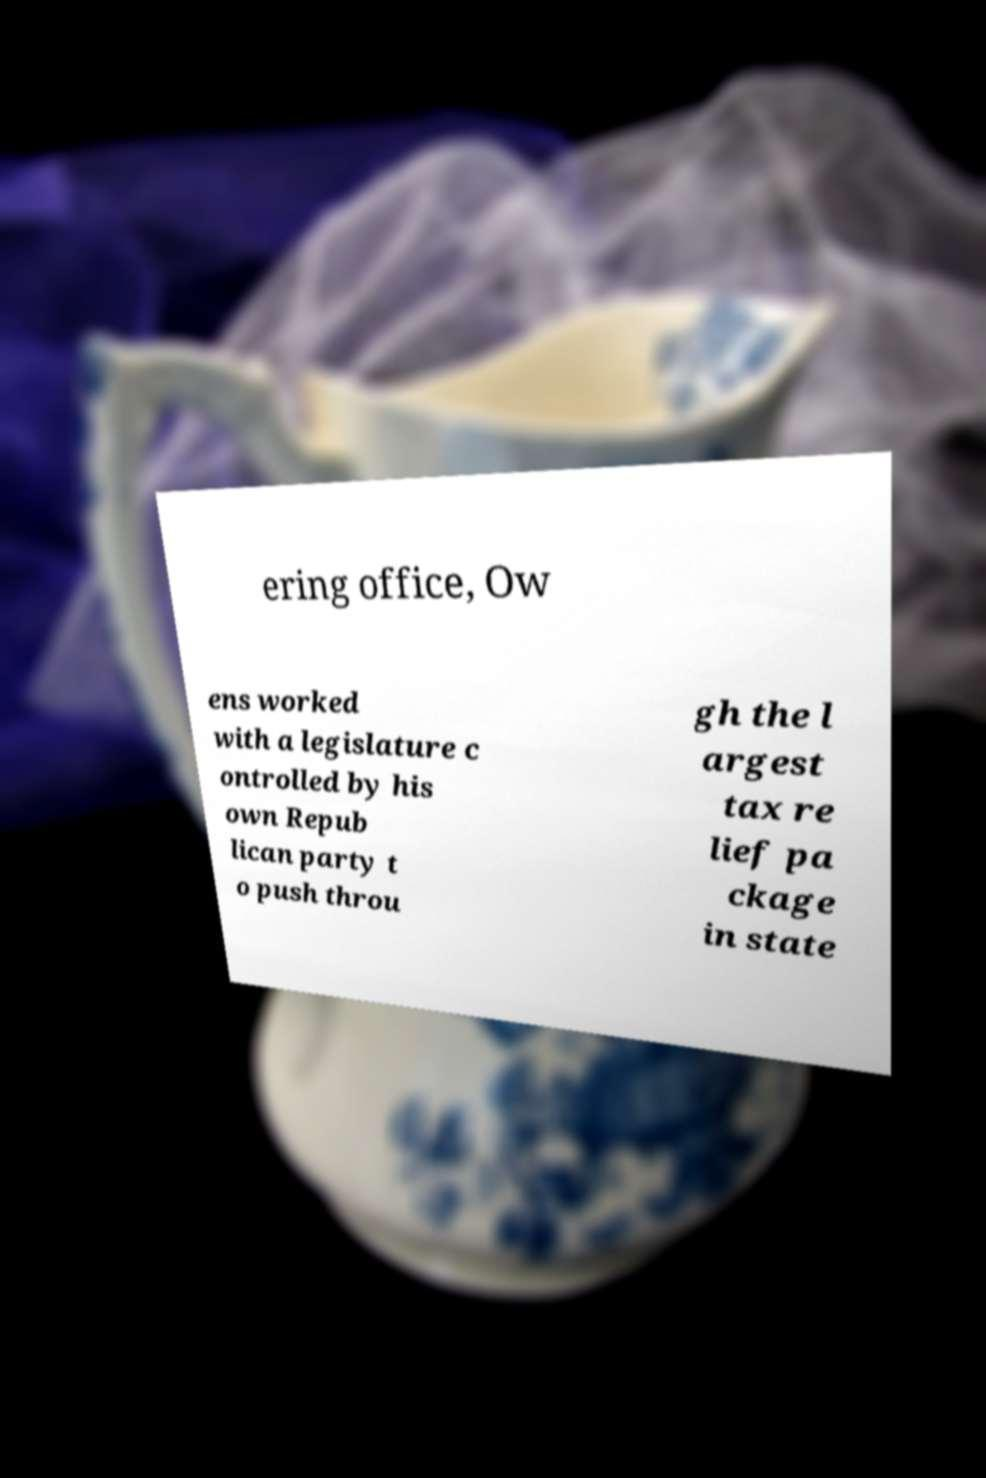Please read and relay the text visible in this image. What does it say? ering office, Ow ens worked with a legislature c ontrolled by his own Repub lican party t o push throu gh the l argest tax re lief pa ckage in state 